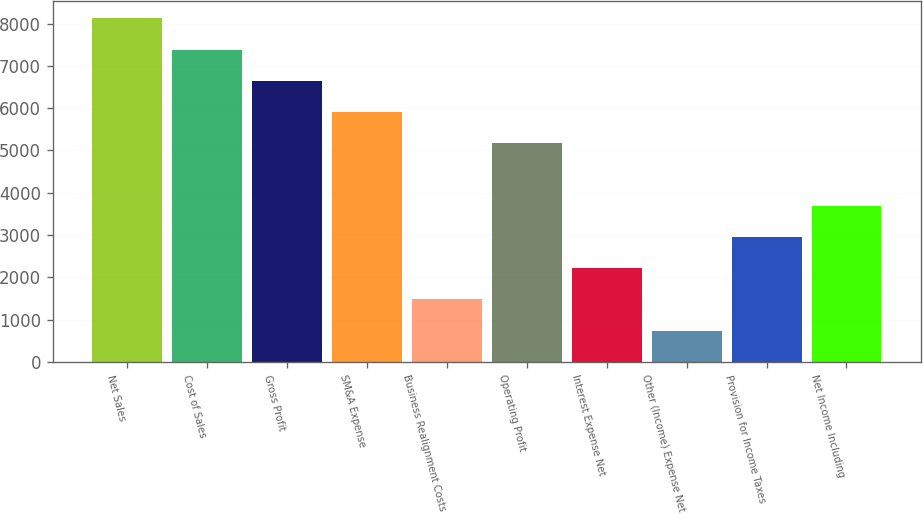<chart> <loc_0><loc_0><loc_500><loc_500><bar_chart><fcel>Net Sales<fcel>Cost of Sales<fcel>Gross Profit<fcel>SM&A Expense<fcel>Business Realignment Costs<fcel>Operating Profit<fcel>Interest Expense Net<fcel>Other (Income) Expense Net<fcel>Provision for Income Taxes<fcel>Net Income Including<nl><fcel>8125.05<fcel>7386.62<fcel>6648.19<fcel>5909.76<fcel>1479.18<fcel>5171.33<fcel>2217.61<fcel>740.75<fcel>2956.04<fcel>3694.47<nl></chart> 